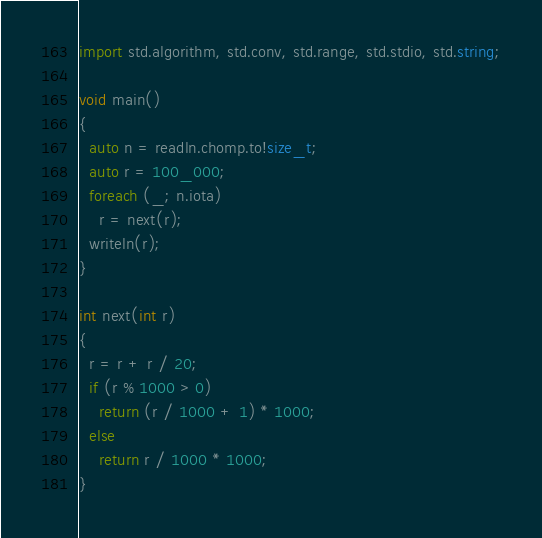Convert code to text. <code><loc_0><loc_0><loc_500><loc_500><_D_>import std.algorithm, std.conv, std.range, std.stdio, std.string;

void main()
{
  auto n = readln.chomp.to!size_t;
  auto r = 100_000;
  foreach (_; n.iota)
    r = next(r);
  writeln(r);
}

int next(int r)
{
  r = r + r / 20;
  if (r % 1000 > 0)
    return (r / 1000 + 1) * 1000;
  else
    return r / 1000 * 1000;
}</code> 